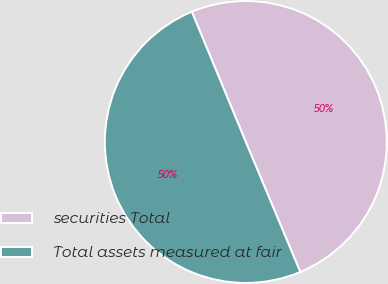Convert chart to OTSL. <chart><loc_0><loc_0><loc_500><loc_500><pie_chart><fcel>securities Total<fcel>Total assets measured at fair<nl><fcel>49.94%<fcel>50.06%<nl></chart> 